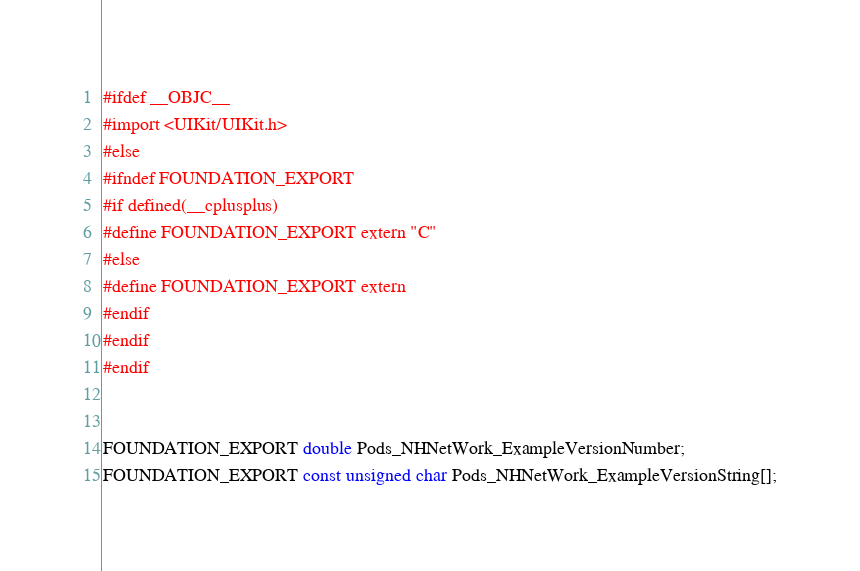<code> <loc_0><loc_0><loc_500><loc_500><_C_>#ifdef __OBJC__
#import <UIKit/UIKit.h>
#else
#ifndef FOUNDATION_EXPORT
#if defined(__cplusplus)
#define FOUNDATION_EXPORT extern "C"
#else
#define FOUNDATION_EXPORT extern
#endif
#endif
#endif


FOUNDATION_EXPORT double Pods_NHNetWork_ExampleVersionNumber;
FOUNDATION_EXPORT const unsigned char Pods_NHNetWork_ExampleVersionString[];

</code> 